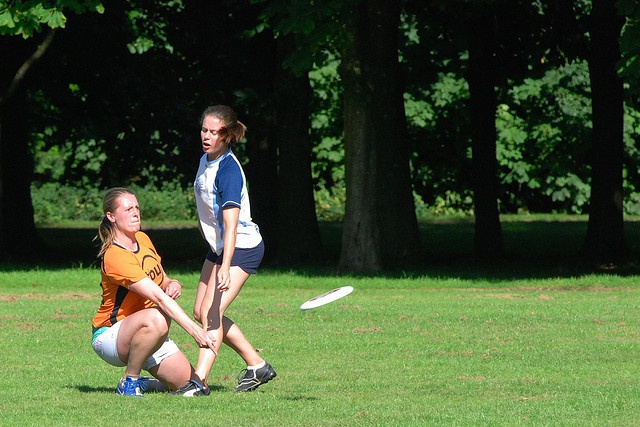Describe the objects in this image and their specific colors. I can see people in darkgreen, white, gray, black, and lightpink tones, people in darkgreen, white, lightpink, orange, and brown tones, and frisbee in darkgreen, white, lightgreen, green, and darkgray tones in this image. 